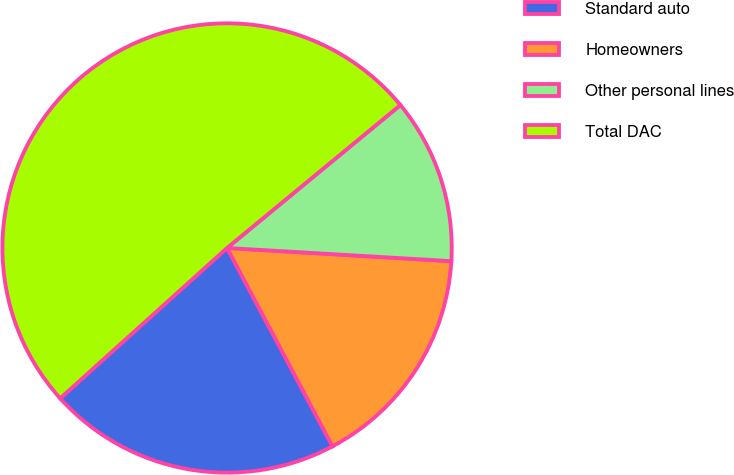Convert chart to OTSL. <chart><loc_0><loc_0><loc_500><loc_500><pie_chart><fcel>Standard auto<fcel>Homeowners<fcel>Other personal lines<fcel>Total DAC<nl><fcel>21.1%<fcel>16.29%<fcel>11.91%<fcel>50.7%<nl></chart> 